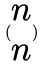Convert formula to latex. <formula><loc_0><loc_0><loc_500><loc_500>( \begin{matrix} n \\ n \end{matrix} )</formula> 